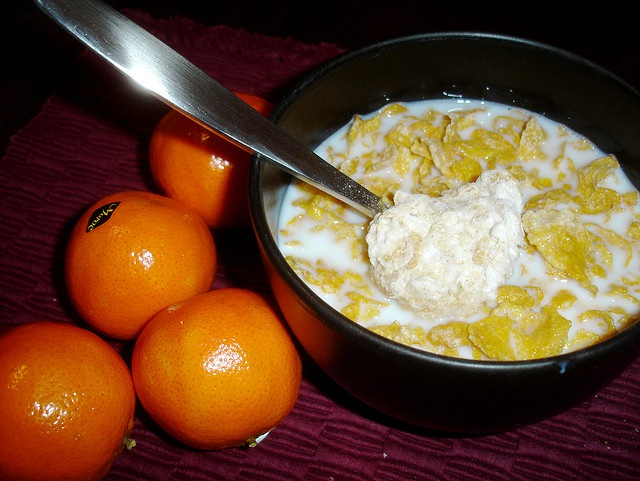Describe the objects in this image and their specific colors. I can see bowl in black, lightgray, tan, and olive tones, orange in black, red, orange, and brown tones, orange in black, brown, red, and maroon tones, orange in black, red, brown, orange, and maroon tones, and spoon in black, gray, darkgray, and white tones in this image. 